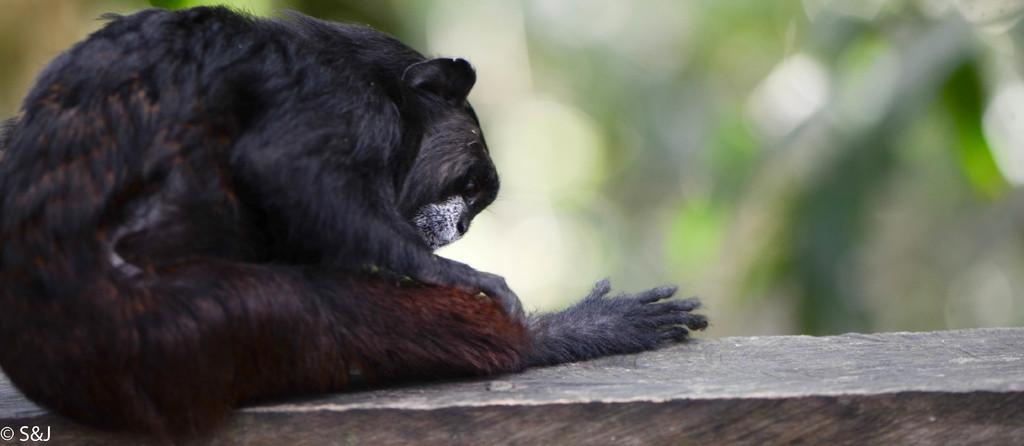What animal is the main subject of the image? There is a black color monkey in the image. What is the monkey doing in the image? The monkey is sitting on a wall. Is there any text or marking in the image? Yes, there is a watermark in the left bottom corner of the image. What can be seen in the background of the image? There are trees in the background of the image. What type of cake is being served on the canvas in the image? There is no cake or canvas present in the image; it features a black color monkey sitting on a wall. What invention is the monkey using to sit on the wall in the image? The monkey is not using any invention to sit on the wall in the image; it is simply sitting on the wall. 